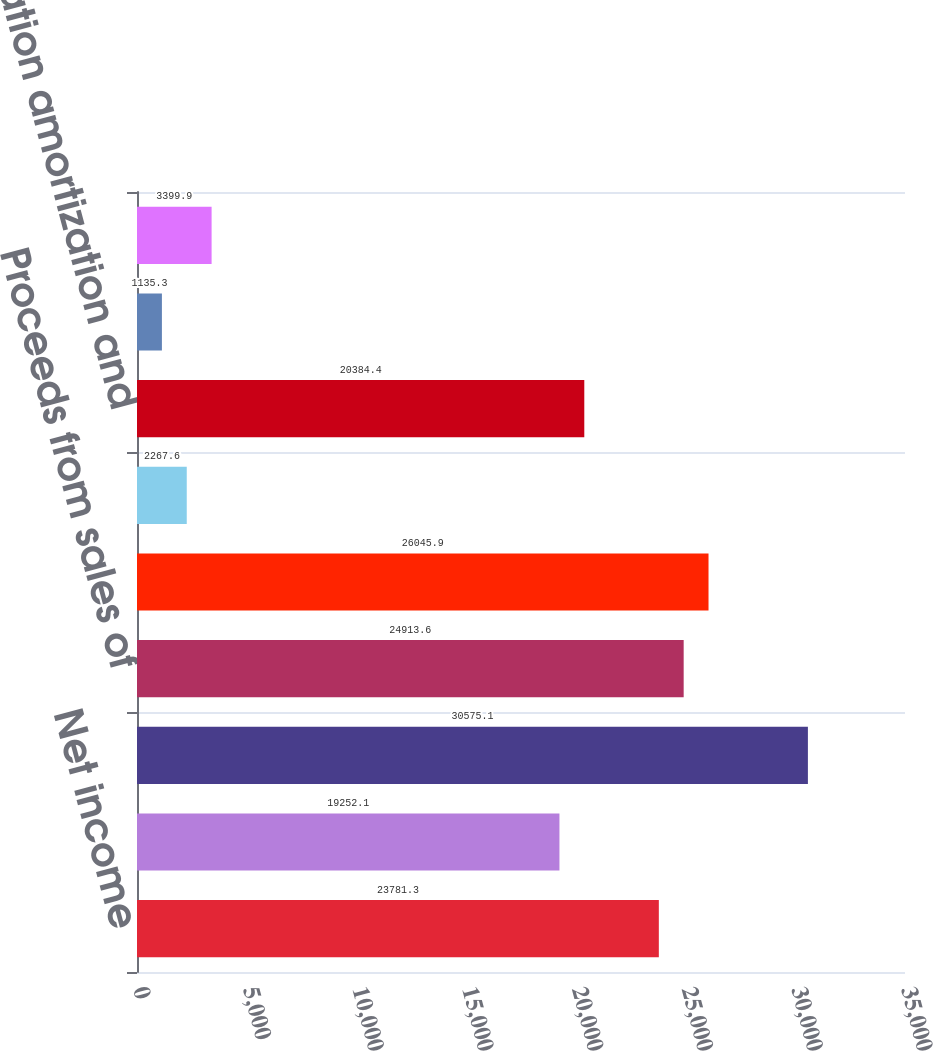Convert chart. <chart><loc_0><loc_0><loc_500><loc_500><bar_chart><fcel>Net income<fcel>Provision for credit losses<fcel>Originations of mortgage loans<fcel>Proceeds from sales of<fcel>Purchases of commercial loans<fcel>Amortization of terminated<fcel>Depreciation amortization and<fcel>Mortgage servicing rights<fcel>Securities impairment<nl><fcel>23781.3<fcel>19252.1<fcel>30575.1<fcel>24913.6<fcel>26045.9<fcel>2267.6<fcel>20384.4<fcel>1135.3<fcel>3399.9<nl></chart> 